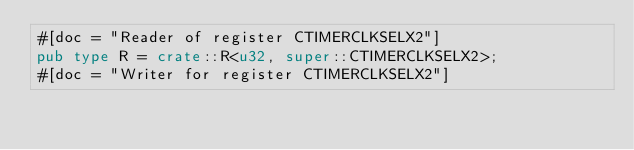Convert code to text. <code><loc_0><loc_0><loc_500><loc_500><_Rust_>#[doc = "Reader of register CTIMERCLKSELX2"]
pub type R = crate::R<u32, super::CTIMERCLKSELX2>;
#[doc = "Writer for register CTIMERCLKSELX2"]</code> 